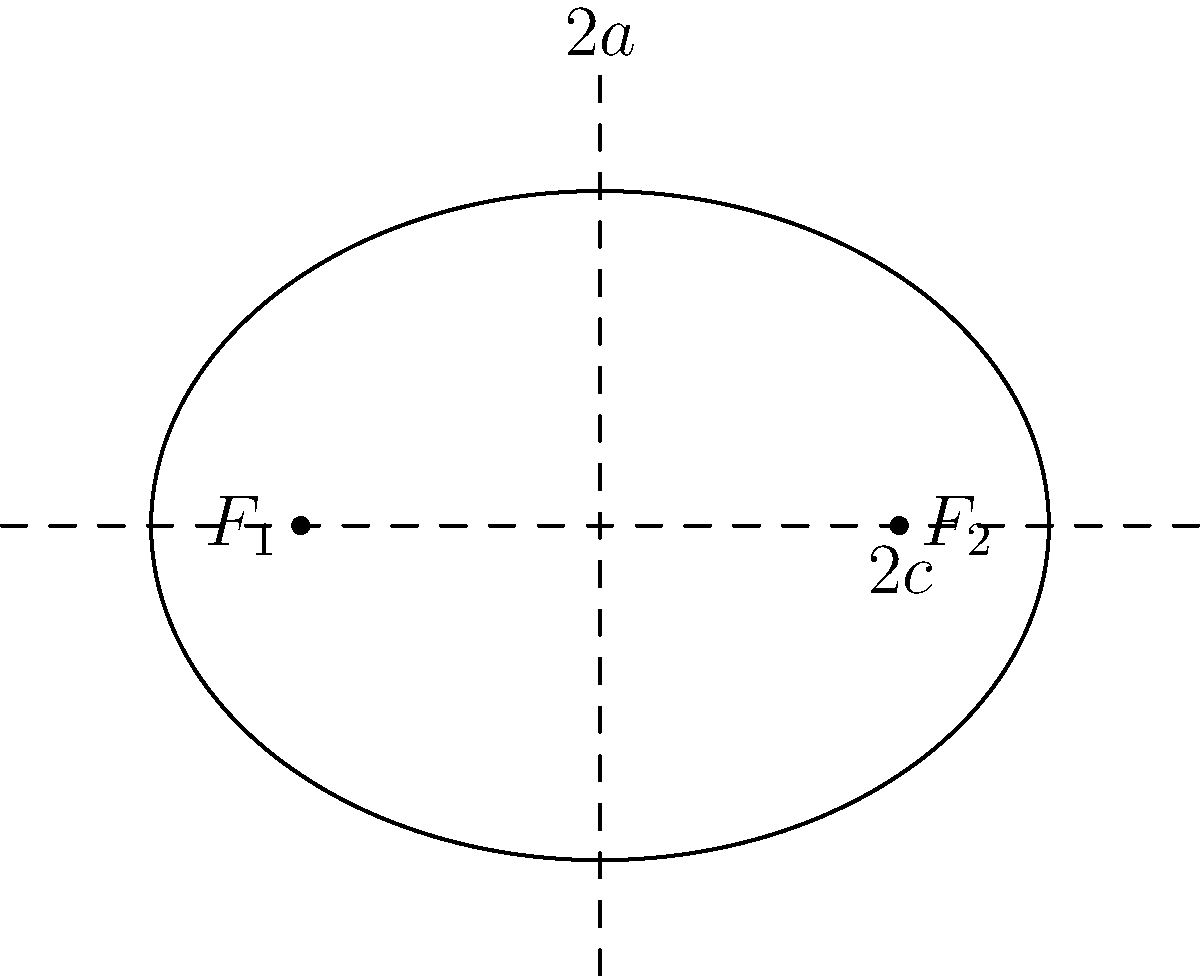Given an ellipse with focal points $F_1(-2,0)$ and $F_2(2,0)$, and eccentricity $e = \frac{2}{3}$, determine the equation of the ellipse in standard form. Let's approach this step-by-step:

1) The distance between the focal points is $2c = 4$, so $c = 2$.

2) The eccentricity is given as $e = \frac{2}{3}$. We know that $e = \frac{c}{a}$, where $a$ is the length of the semi-major axis.

3) Substituting the known values:

   $\frac{2}{3} = \frac{2}{a}$

4) Solving for $a$:

   $a = 2 \cdot \frac{3}{2} = 3$

5) Now we can find $b$ (the length of the semi-minor axis) using the Pythagorean theorem:

   $a^2 = b^2 + c^2$
   $3^2 = b^2 + 2^2$
   $9 = b^2 + 4$
   $b^2 = 5$
   $b = \sqrt{5}$

6) The standard form of an ellipse centered at the origin is:

   $\frac{x^2}{a^2} + \frac{y^2}{b^2} = 1$

7) Substituting our values:

   $\frac{x^2}{3^2} + \frac{y^2}{(\sqrt{5})^2} = 1$

8) Simplifying:

   $\frac{x^2}{9} + \frac{y^2}{5} = 1$
Answer: $\frac{x^2}{9} + \frac{y^2}{5} = 1$ 